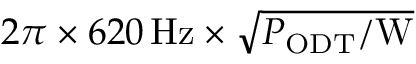Convert formula to latex. <formula><loc_0><loc_0><loc_500><loc_500>2 \pi \times 6 2 0 \, H z \times \sqrt { P _ { O D T } / W }</formula> 